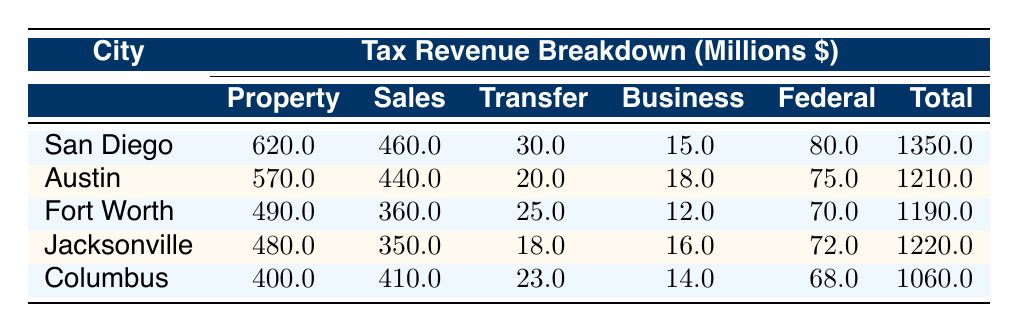What is the total revenue for San Diego? The total revenue for San Diego is found in the last column of the row for San Diego, which states 1350 million dollars.
Answer: 1350 million dollars Which city has the highest property tax revenue? By comparing the property tax revenues listed for each city, San Diego’s property tax revenue at 620 million is the highest.
Answer: San Diego What is the average amount of sales tax collected across these cities? To find the average sales tax, first sum the sales tax amount: 460 + 440 + 360 + 350 + 410 = 2020 million. Then, divide by the number of cities (5): 2020 / 5 = 404 million dollars.
Answer: 404 million dollars Is there any city that collects income tax? The table shows zero income tax revenue for all listed cities, so the answer is no.
Answer: No What is the difference in total revenue between Austin and Columbus? To find the difference, subtract Columbus's total revenue from Austin's: 1210 million (Austin) - 1060 million (Columbus) = 150 million dollars.
Answer: 150 million dollars Which city has the lowest federal grants revenue? By checking the federal grants column, Columbus has the lowest amount at 68 million dollars.
Answer: Columbus What is the total property transfer tax revenue collected by all cities? Add together the property transfer tax revenues for each city: 30 + 20 + 25 + 18 + 23 = 116 million dollars.
Answer: 116 million dollars If we combine the sales tax revenues of San Diego and Fort Worth, what do we get? Adding San Diego's sales tax (460 million) and Fort Worth's sales tax (360 million) gives: 460 + 360 = 820 million dollars.
Answer: 820 million dollars Which city has the highest total revenue when comparing all cities? Looking at the total revenues, San Diego has the highest at 1350 million dollars compared to others.
Answer: San Diego What percentage of Columbus's total revenue comes from property tax? Columbus's property tax is 400 million, and the total revenue is 1060 million. The percentage is (400 / 1060) * 100 ≈ 37.74%.
Answer: Approximately 37.74% 